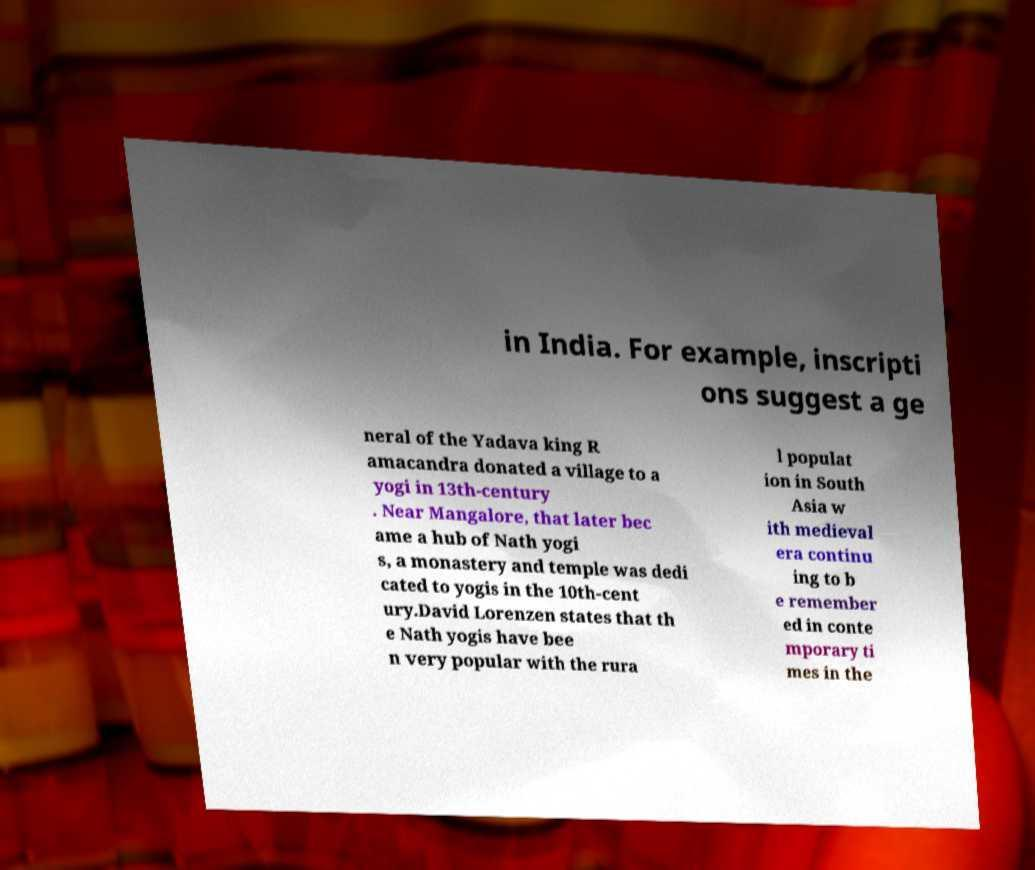Please identify and transcribe the text found in this image. in India. For example, inscripti ons suggest a ge neral of the Yadava king R amacandra donated a village to a yogi in 13th-century . Near Mangalore, that later bec ame a hub of Nath yogi s, a monastery and temple was dedi cated to yogis in the 10th-cent ury.David Lorenzen states that th e Nath yogis have bee n very popular with the rura l populat ion in South Asia w ith medieval era continu ing to b e remember ed in conte mporary ti mes in the 